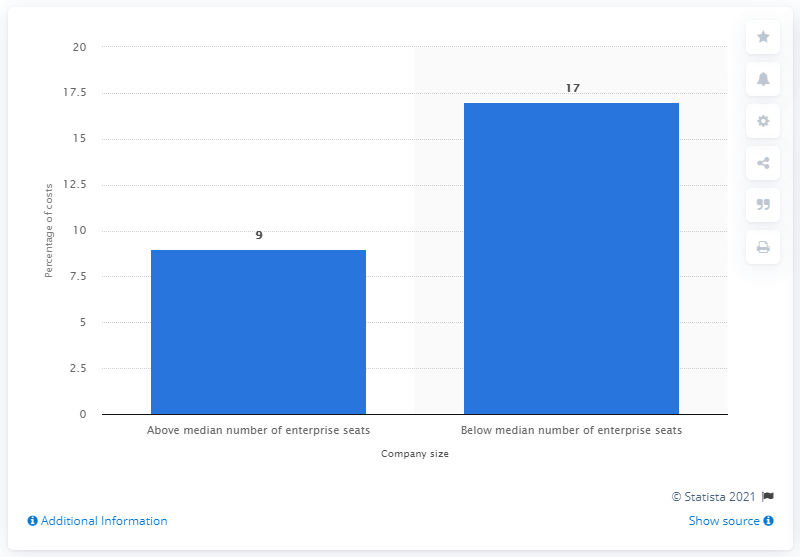Specify some key components in this picture. According to the data, companies with a lower number of enterprise seats (below the median of 13,251) bore a smaller share of the total cost of cybercrime compared to companies with a higher number of seats. Specifically, approximately 17% of cybercrime costs were incurred by companies with fewer than 13,251 enterprise seats. 